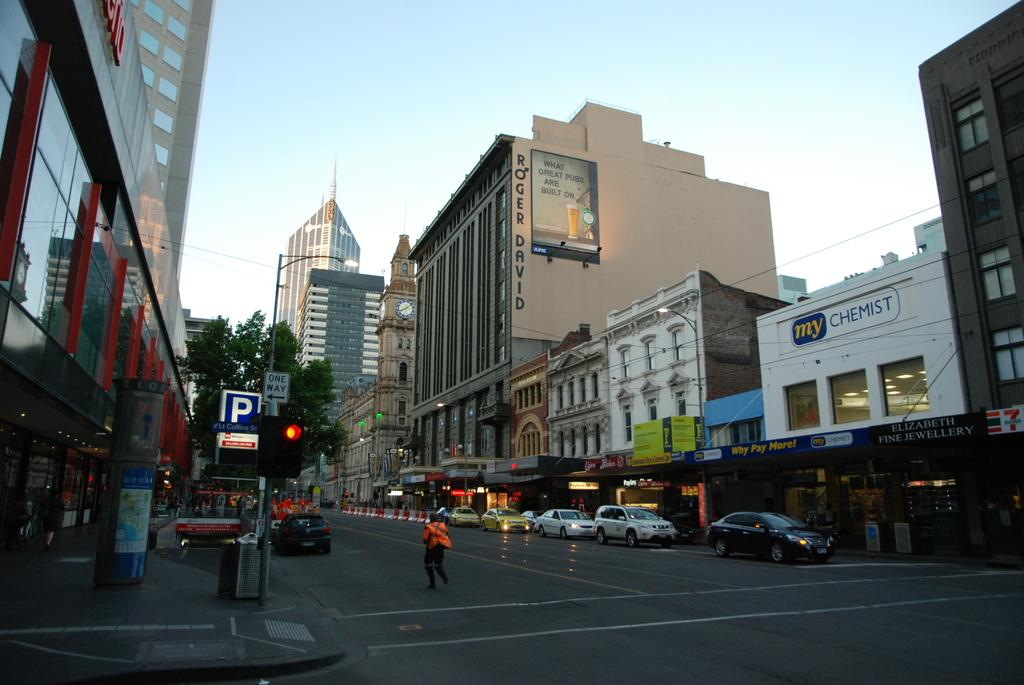What type of structures can be seen in the image? There are buildings in the image. What architectural features are present on the buildings? There are windows visible on the buildings. What natural element is present in the image? There is a tree in the image. What traffic control device is present in the image? There is a traffic signal in the image. What type of vehicles can be seen in the image? There are cars in the image. What human activity is depicted in the image? There is a person walking in the image. What additional signage is present in the image? There is a banner in the image. What is visible at the top of the image? The sky is visible at the top of the image. Where is the church located in the image? There is no church present in the image. What rule is being enforced by the banner in the image? The banner in the image does not enforce any rules; it is likely an advertisement or informational sign. 